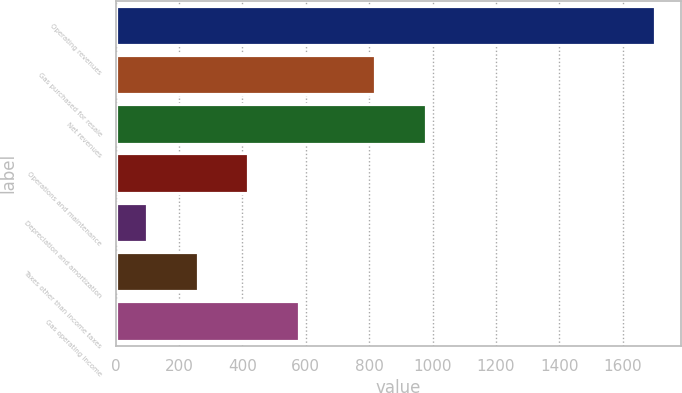Convert chart to OTSL. <chart><loc_0><loc_0><loc_500><loc_500><bar_chart><fcel>Operating revenues<fcel>Gas purchased for resale<fcel>Net revenues<fcel>Operations and maintenance<fcel>Depreciation and amortization<fcel>Taxes other than income taxes<fcel>Gas operating income<nl><fcel>1701<fcel>818<fcel>978.3<fcel>418.6<fcel>98<fcel>258.3<fcel>578.9<nl></chart> 